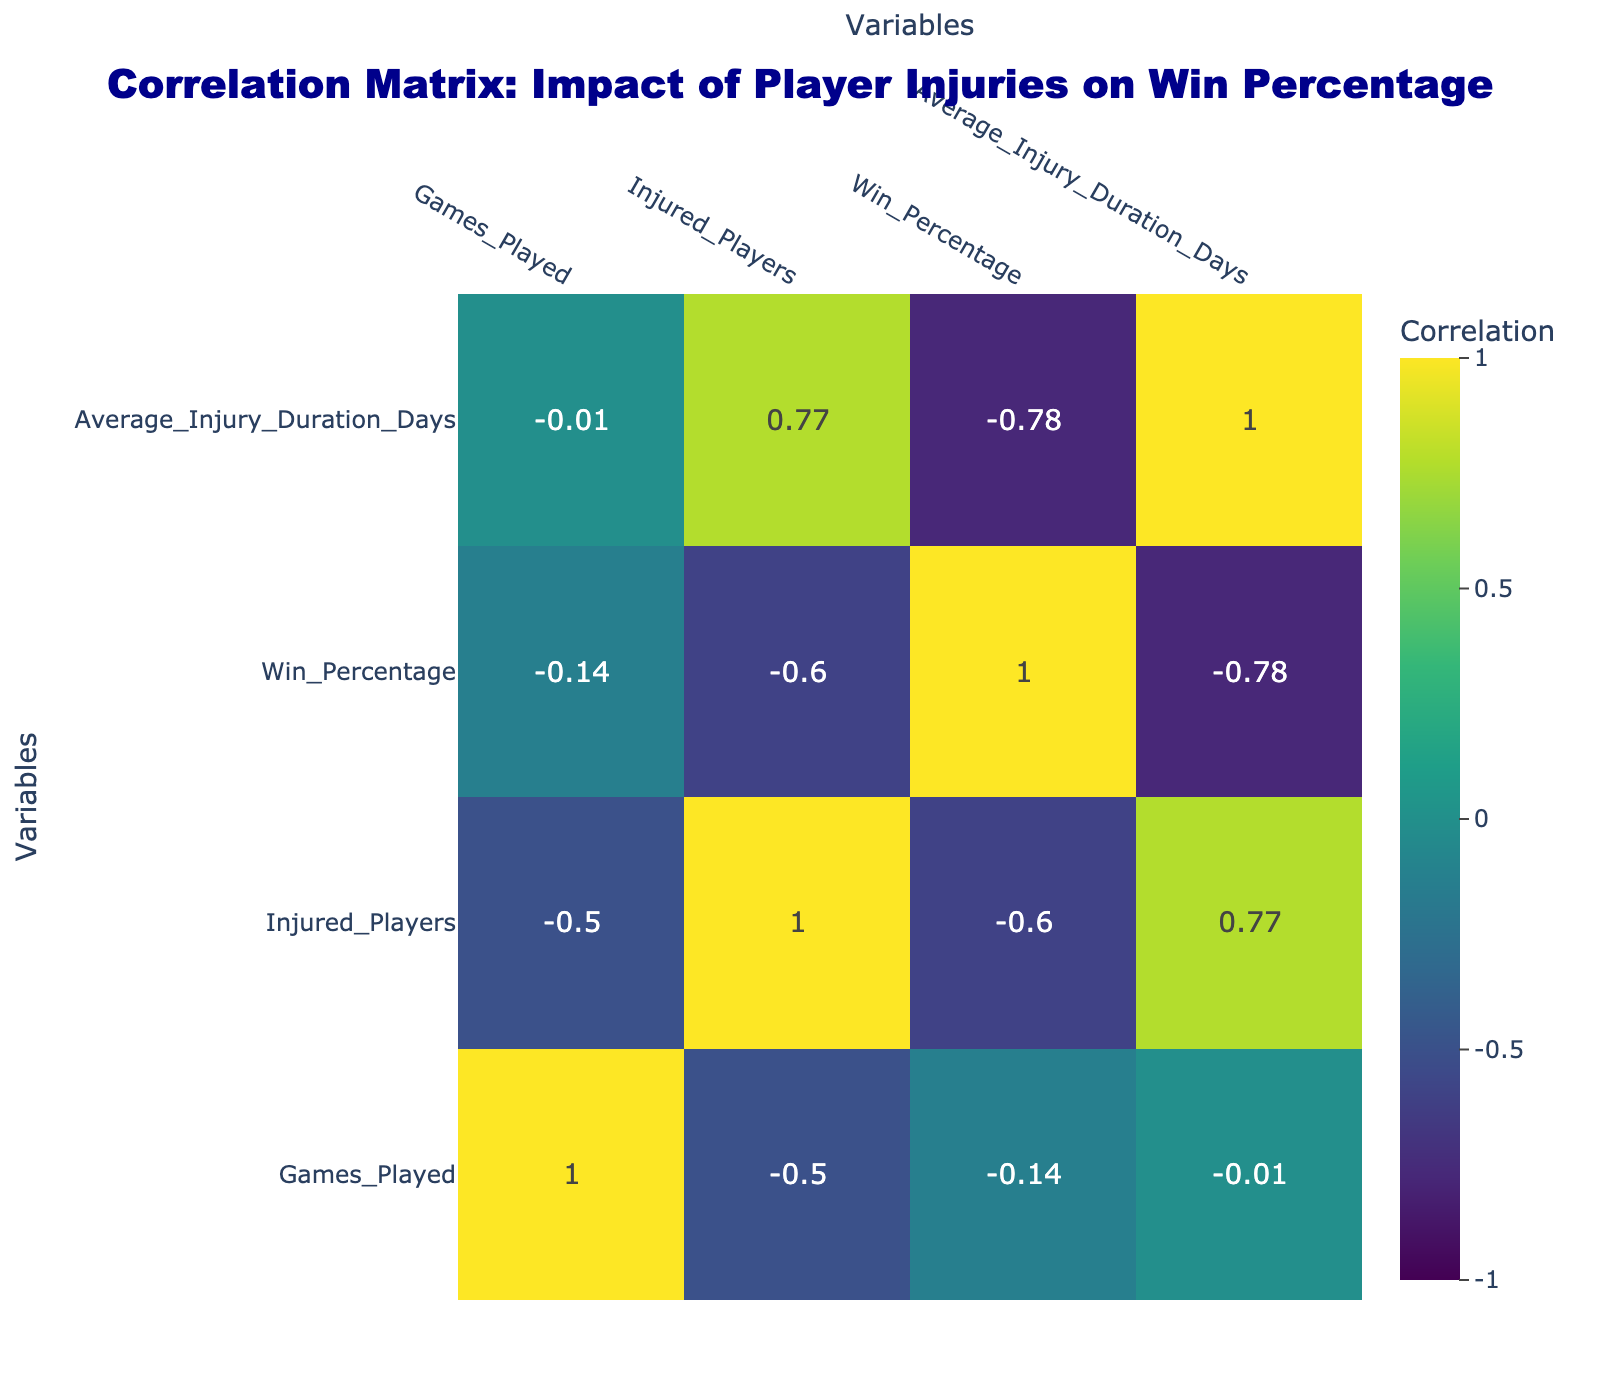What's the win percentage of Arsenal in the 2022/2023 season? Arsenal has a win percentage of 63.16% in the 2022/2023 season, as indicated in the table under the "Win_Percentage" column.
Answer: 63.16% How many injured players did Chelsea have in the 2022/2023 season? Chelsea had 5 injured players in the 2022/2023 season, as stated in the "Injured_Players" column.
Answer: 5 What is the average injury duration for Borussia Dortmund players? The average injury duration for Borussia Dortmund players is 26 days, which can be found in the "Average_Injury_Duration_Days" column.
Answer: 26 Which team had the highest win percentage among teams with 4 injured players? Paris Saint-Germain had the highest win percentage (78.95%) among the teams with 4 injured players, as their win percentage is listed in the "Win_Percentage" column.
Answer: Paris Saint-Germain Is there a correlation between the number of injured players and win percentage? Yes, the correlation coefficient between injured players and win percentage is negative, suggesting that an increase in injured players is associated with a decrease in win percentage.
Answer: Yes What is the difference in win percentage between the teams with the highest and lowest injuries? The team with the highest number of injured players is Tottenham Hotspur (6 players) with a win percentage of 47.37%, while the team with the lowest (2 players) is Manchester City with a percentage of 76.32%. The difference is 76.32 - 47.37 = 28.95%.
Answer: 28.95% Which league had the team with the most injured players? The Premier League had Tottenham Hotspur with 6 injured players, which is the highest number in the data.
Answer: Premier League What is the average win percentage for teams in the Bundesliga? To find the average win percentage for the Bundesliga, we sum the win percentages of Bayern Munich (70.59) and Borussia Dortmund (62.24) and divide by 2, which gives (70.59 + 62.24) / 2 = 66.42%.
Answer: 66.42% Which team sustained injuries for the shortest duration on average? Manchester City had the shortest average injury duration at 15 days, according to the "Average_Injury_Duration_Days" column.
Answer: Manchester City 